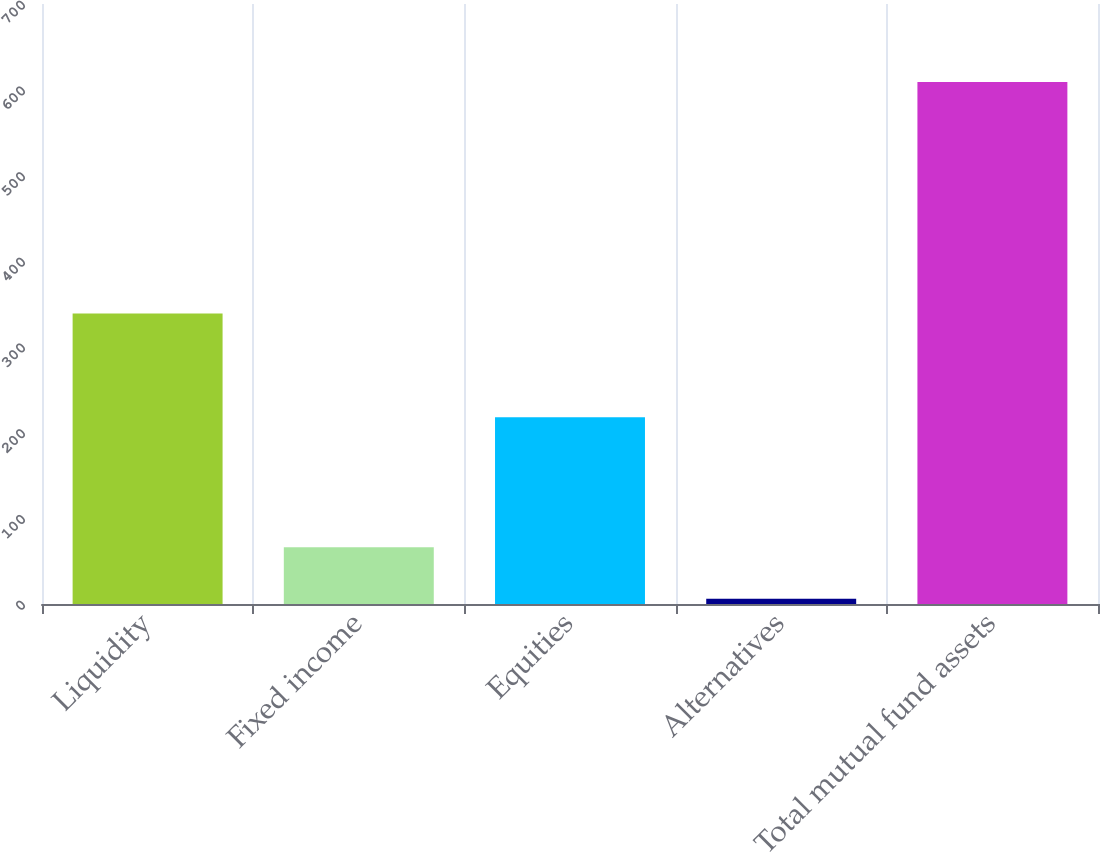Convert chart. <chart><loc_0><loc_0><loc_500><loc_500><bar_chart><fcel>Liquidity<fcel>Fixed income<fcel>Equities<fcel>Alternatives<fcel>Total mutual fund assets<nl><fcel>339<fcel>66.3<fcel>218<fcel>6<fcel>609<nl></chart> 